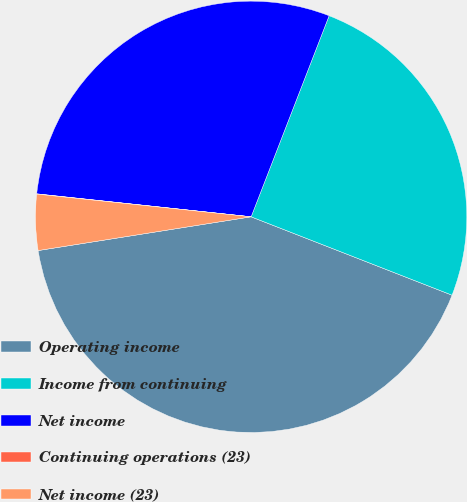Convert chart. <chart><loc_0><loc_0><loc_500><loc_500><pie_chart><fcel>Operating income<fcel>Income from continuing<fcel>Net income<fcel>Continuing operations (23)<fcel>Net income (23)<nl><fcel>41.58%<fcel>25.03%<fcel>29.19%<fcel>0.02%<fcel>4.18%<nl></chart> 